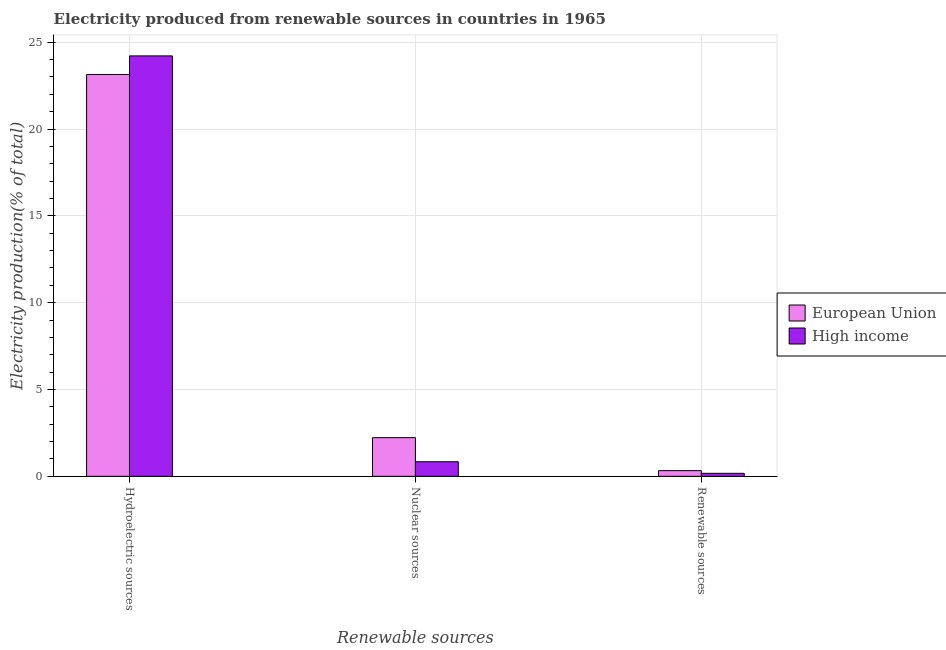How many groups of bars are there?
Give a very brief answer. 3. How many bars are there on the 2nd tick from the right?
Your answer should be compact. 2. What is the label of the 2nd group of bars from the left?
Provide a succinct answer. Nuclear sources. What is the percentage of electricity produced by nuclear sources in European Union?
Your response must be concise. 2.23. Across all countries, what is the maximum percentage of electricity produced by hydroelectric sources?
Provide a short and direct response. 24.22. Across all countries, what is the minimum percentage of electricity produced by hydroelectric sources?
Keep it short and to the point. 23.14. In which country was the percentage of electricity produced by renewable sources maximum?
Provide a short and direct response. European Union. In which country was the percentage of electricity produced by renewable sources minimum?
Ensure brevity in your answer.  High income. What is the total percentage of electricity produced by hydroelectric sources in the graph?
Your answer should be very brief. 47.36. What is the difference between the percentage of electricity produced by nuclear sources in High income and that in European Union?
Your answer should be very brief. -1.39. What is the difference between the percentage of electricity produced by hydroelectric sources in European Union and the percentage of electricity produced by renewable sources in High income?
Keep it short and to the point. 22.97. What is the average percentage of electricity produced by nuclear sources per country?
Offer a very short reply. 1.53. What is the difference between the percentage of electricity produced by nuclear sources and percentage of electricity produced by renewable sources in European Union?
Offer a very short reply. 1.9. What is the ratio of the percentage of electricity produced by nuclear sources in High income to that in European Union?
Ensure brevity in your answer.  0.38. Is the difference between the percentage of electricity produced by renewable sources in High income and European Union greater than the difference between the percentage of electricity produced by nuclear sources in High income and European Union?
Your answer should be very brief. Yes. What is the difference between the highest and the second highest percentage of electricity produced by nuclear sources?
Offer a terse response. 1.39. What is the difference between the highest and the lowest percentage of electricity produced by nuclear sources?
Provide a succinct answer. 1.39. What does the 2nd bar from the left in Renewable sources represents?
Your response must be concise. High income. How many bars are there?
Your answer should be very brief. 6. Are all the bars in the graph horizontal?
Your answer should be very brief. No. How many countries are there in the graph?
Provide a short and direct response. 2. What is the difference between two consecutive major ticks on the Y-axis?
Ensure brevity in your answer.  5. Does the graph contain grids?
Offer a terse response. Yes. How are the legend labels stacked?
Give a very brief answer. Vertical. What is the title of the graph?
Provide a short and direct response. Electricity produced from renewable sources in countries in 1965. What is the label or title of the X-axis?
Provide a short and direct response. Renewable sources. What is the label or title of the Y-axis?
Offer a terse response. Electricity production(% of total). What is the Electricity production(% of total) in European Union in Hydroelectric sources?
Provide a succinct answer. 23.14. What is the Electricity production(% of total) in High income in Hydroelectric sources?
Provide a short and direct response. 24.22. What is the Electricity production(% of total) in European Union in Nuclear sources?
Provide a short and direct response. 2.23. What is the Electricity production(% of total) in High income in Nuclear sources?
Ensure brevity in your answer.  0.84. What is the Electricity production(% of total) of European Union in Renewable sources?
Provide a short and direct response. 0.33. What is the Electricity production(% of total) in High income in Renewable sources?
Provide a short and direct response. 0.17. Across all Renewable sources, what is the maximum Electricity production(% of total) in European Union?
Offer a very short reply. 23.14. Across all Renewable sources, what is the maximum Electricity production(% of total) of High income?
Make the answer very short. 24.22. Across all Renewable sources, what is the minimum Electricity production(% of total) in European Union?
Give a very brief answer. 0.33. Across all Renewable sources, what is the minimum Electricity production(% of total) in High income?
Provide a succinct answer. 0.17. What is the total Electricity production(% of total) in European Union in the graph?
Make the answer very short. 25.7. What is the total Electricity production(% of total) of High income in the graph?
Offer a terse response. 25.23. What is the difference between the Electricity production(% of total) in European Union in Hydroelectric sources and that in Nuclear sources?
Provide a succinct answer. 20.92. What is the difference between the Electricity production(% of total) in High income in Hydroelectric sources and that in Nuclear sources?
Provide a short and direct response. 23.38. What is the difference between the Electricity production(% of total) of European Union in Hydroelectric sources and that in Renewable sources?
Make the answer very short. 22.82. What is the difference between the Electricity production(% of total) in High income in Hydroelectric sources and that in Renewable sources?
Offer a very short reply. 24.04. What is the difference between the Electricity production(% of total) of European Union in Nuclear sources and that in Renewable sources?
Ensure brevity in your answer.  1.9. What is the difference between the Electricity production(% of total) of High income in Nuclear sources and that in Renewable sources?
Keep it short and to the point. 0.67. What is the difference between the Electricity production(% of total) of European Union in Hydroelectric sources and the Electricity production(% of total) of High income in Nuclear sources?
Ensure brevity in your answer.  22.3. What is the difference between the Electricity production(% of total) of European Union in Hydroelectric sources and the Electricity production(% of total) of High income in Renewable sources?
Give a very brief answer. 22.97. What is the difference between the Electricity production(% of total) in European Union in Nuclear sources and the Electricity production(% of total) in High income in Renewable sources?
Give a very brief answer. 2.05. What is the average Electricity production(% of total) of European Union per Renewable sources?
Keep it short and to the point. 8.57. What is the average Electricity production(% of total) in High income per Renewable sources?
Provide a short and direct response. 8.41. What is the difference between the Electricity production(% of total) of European Union and Electricity production(% of total) of High income in Hydroelectric sources?
Keep it short and to the point. -1.07. What is the difference between the Electricity production(% of total) in European Union and Electricity production(% of total) in High income in Nuclear sources?
Provide a short and direct response. 1.39. What is the difference between the Electricity production(% of total) of European Union and Electricity production(% of total) of High income in Renewable sources?
Provide a succinct answer. 0.15. What is the ratio of the Electricity production(% of total) of European Union in Hydroelectric sources to that in Nuclear sources?
Keep it short and to the point. 10.4. What is the ratio of the Electricity production(% of total) of High income in Hydroelectric sources to that in Nuclear sources?
Your answer should be compact. 28.82. What is the ratio of the Electricity production(% of total) of European Union in Hydroelectric sources to that in Renewable sources?
Provide a succinct answer. 70.88. What is the ratio of the Electricity production(% of total) in High income in Hydroelectric sources to that in Renewable sources?
Your answer should be compact. 140.48. What is the ratio of the Electricity production(% of total) of European Union in Nuclear sources to that in Renewable sources?
Make the answer very short. 6.82. What is the ratio of the Electricity production(% of total) in High income in Nuclear sources to that in Renewable sources?
Make the answer very short. 4.87. What is the difference between the highest and the second highest Electricity production(% of total) of European Union?
Offer a terse response. 20.92. What is the difference between the highest and the second highest Electricity production(% of total) of High income?
Keep it short and to the point. 23.38. What is the difference between the highest and the lowest Electricity production(% of total) of European Union?
Provide a short and direct response. 22.82. What is the difference between the highest and the lowest Electricity production(% of total) of High income?
Offer a terse response. 24.04. 